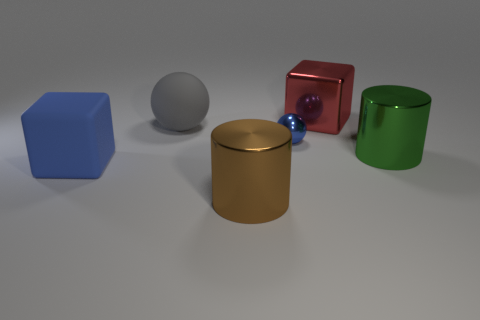Add 3 blue metal objects. How many objects exist? 9 Subtract all spheres. How many objects are left? 4 Subtract 0 brown balls. How many objects are left? 6 Subtract all red metal objects. Subtract all large blue metal spheres. How many objects are left? 5 Add 2 big brown objects. How many big brown objects are left? 3 Add 5 tiny gray balls. How many tiny gray balls exist? 5 